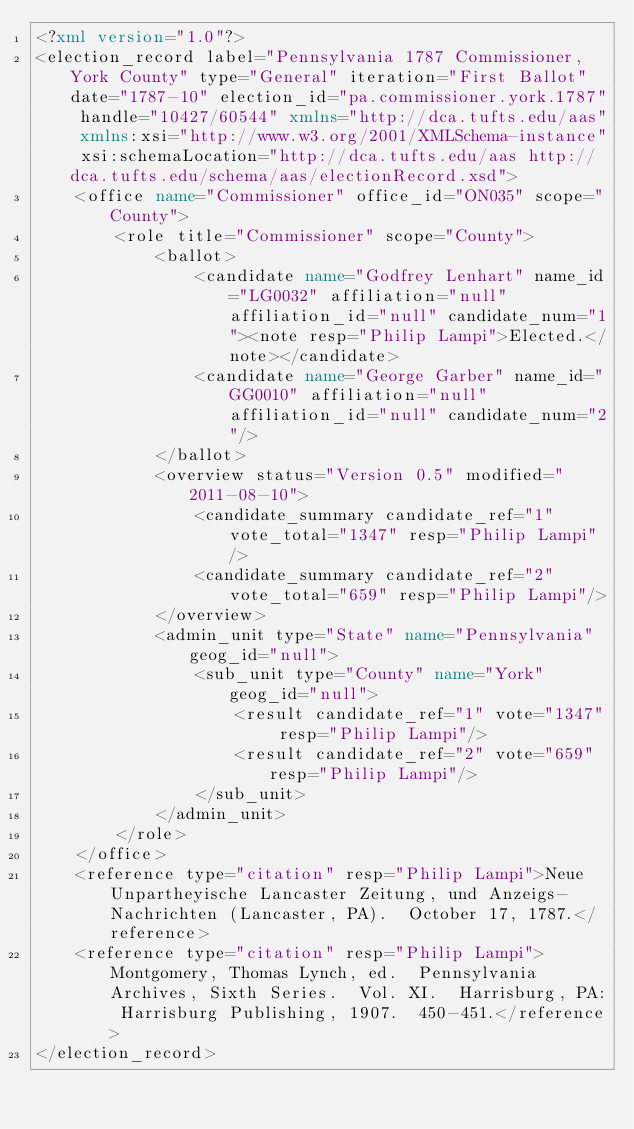Convert code to text. <code><loc_0><loc_0><loc_500><loc_500><_XML_><?xml version="1.0"?>
<election_record label="Pennsylvania 1787 Commissioner, York County" type="General" iteration="First Ballot" date="1787-10" election_id="pa.commissioner.york.1787" handle="10427/60544" xmlns="http://dca.tufts.edu/aas" xmlns:xsi="http://www.w3.org/2001/XMLSchema-instance" xsi:schemaLocation="http://dca.tufts.edu/aas http://dca.tufts.edu/schema/aas/electionRecord.xsd">
    <office name="Commissioner" office_id="ON035" scope="County">
        <role title="Commissioner" scope="County">
            <ballot>
                <candidate name="Godfrey Lenhart" name_id="LG0032" affiliation="null" affiliation_id="null" candidate_num="1"><note resp="Philip Lampi">Elected.</note></candidate>
                <candidate name="George Garber" name_id="GG0010" affiliation="null" affiliation_id="null" candidate_num="2"/>
            </ballot>
            <overview status="Version 0.5" modified="2011-08-10">
                <candidate_summary candidate_ref="1" vote_total="1347" resp="Philip Lampi"/>
                <candidate_summary candidate_ref="2" vote_total="659" resp="Philip Lampi"/>
            </overview>
            <admin_unit type="State" name="Pennsylvania" geog_id="null">
                <sub_unit type="County" name="York" geog_id="null">
                    <result candidate_ref="1" vote="1347" resp="Philip Lampi"/>
                    <result candidate_ref="2" vote="659" resp="Philip Lampi"/>  
                </sub_unit>
            </admin_unit>
        </role>
    </office>
    <reference type="citation" resp="Philip Lampi">Neue Unpartheyische Lancaster Zeitung, und Anzeigs-Nachrichten (Lancaster, PA).  October 17, 1787.</reference>
    <reference type="citation" resp="Philip Lampi">Montgomery, Thomas Lynch, ed.  Pennsylvania Archives, Sixth Series.  Vol. XI.  Harrisburg, PA: Harrisburg Publishing, 1907.  450-451.</reference>
</election_record>
</code> 